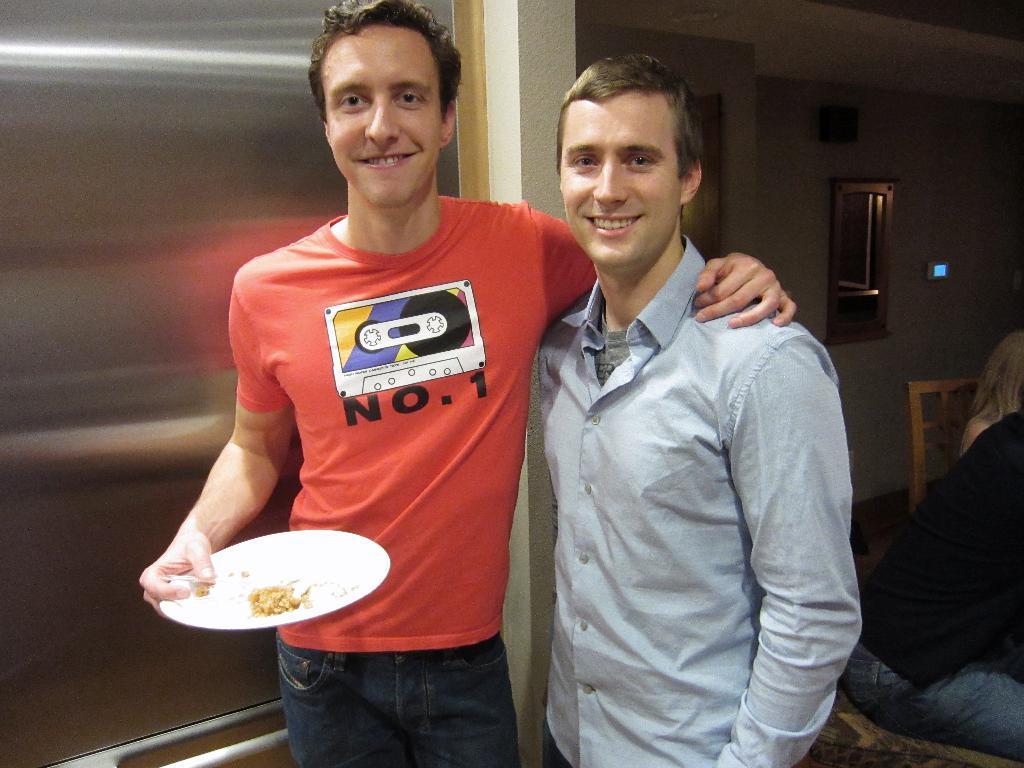Please provide a concise description of this image. 2 men are standing. The person at the left is wearing a red t shirt and holding a white plate of food item. 2 people are sitting at the left. There is a mirror at the back. 